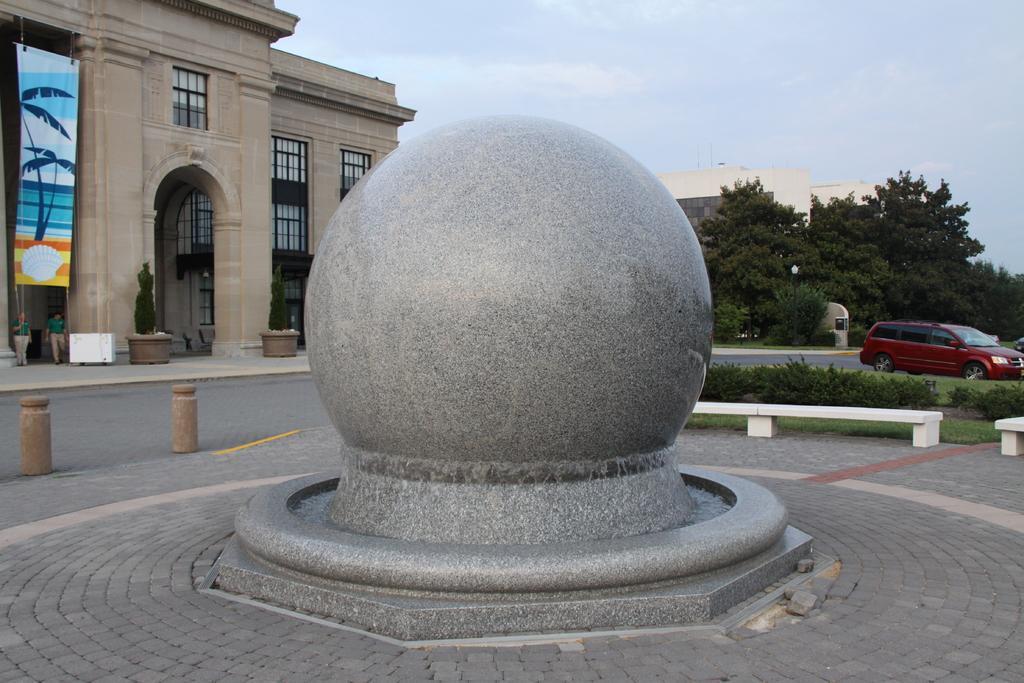Can you describe this image briefly? In this picture, it seems like a round stone in the foreground, there are buildings, trees, people, car and the sky in the background. 